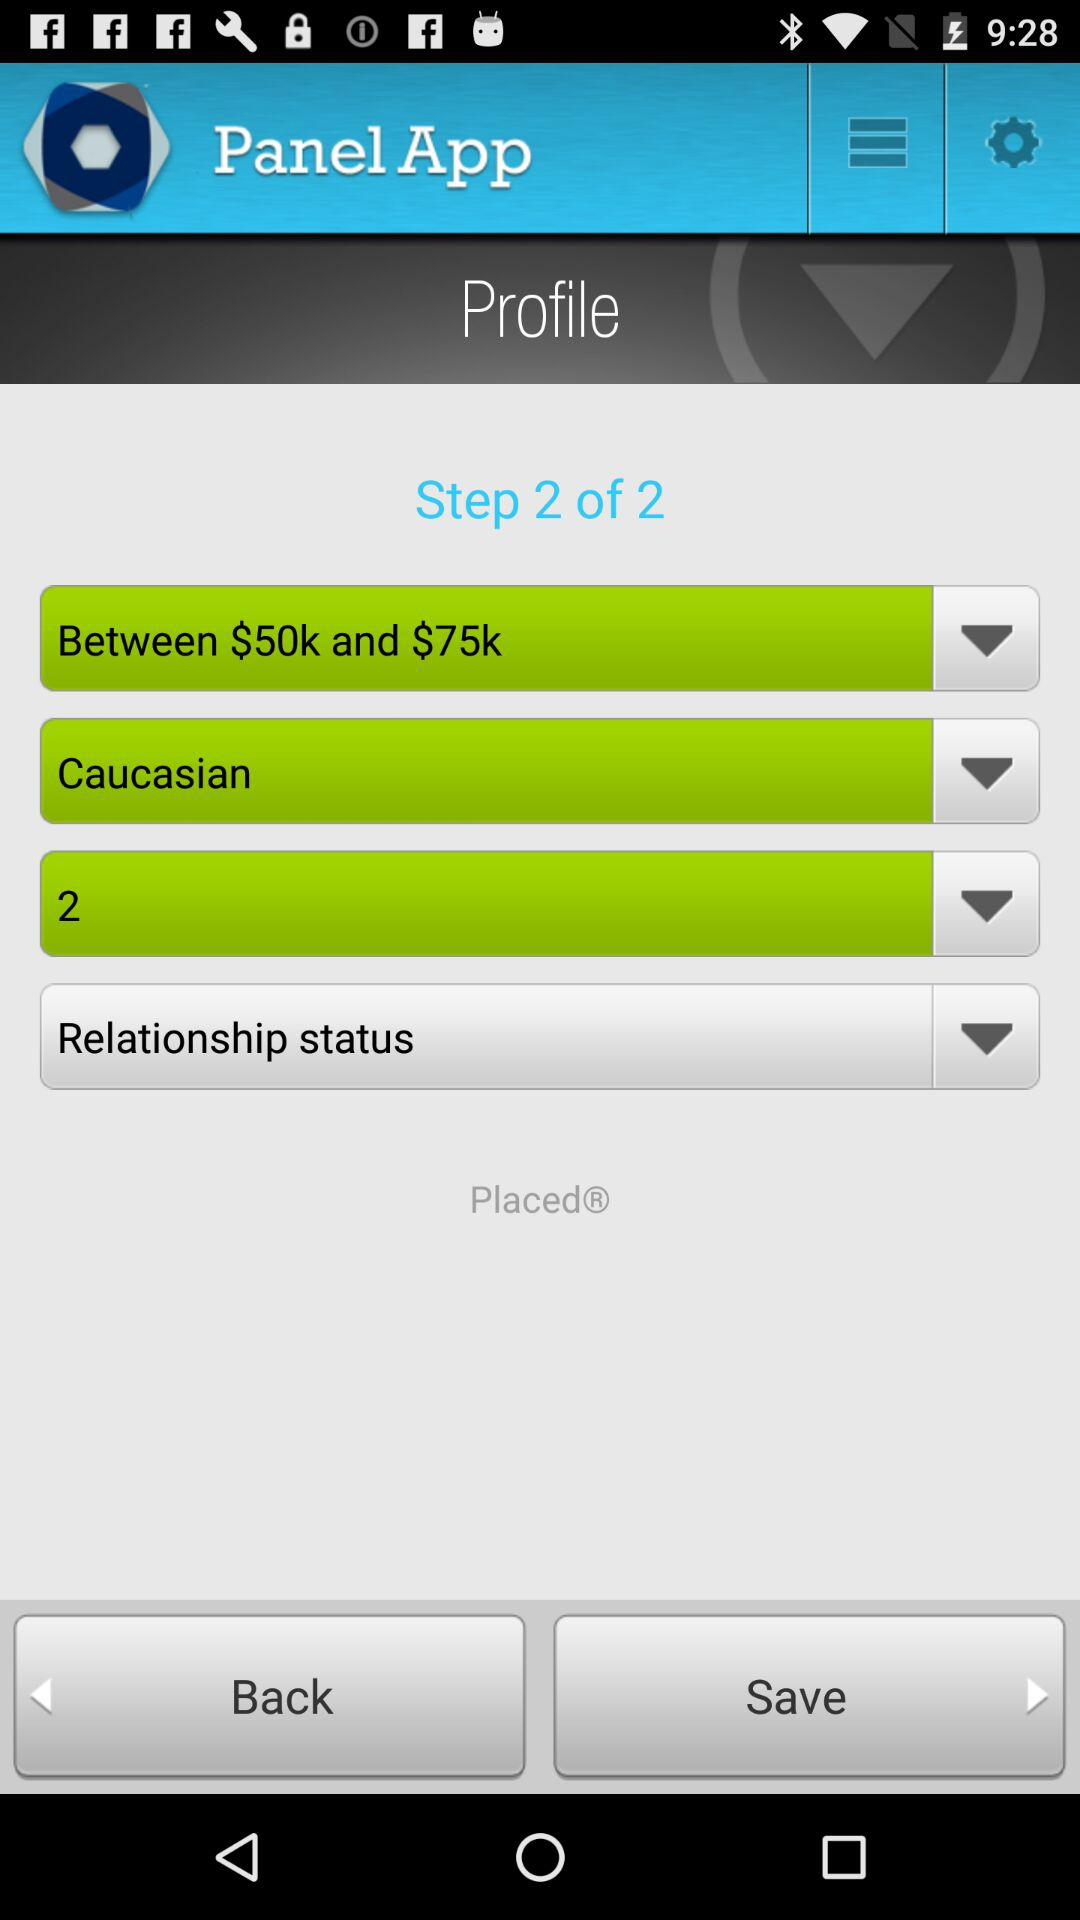What is the application name? The application name is "Panel App". 